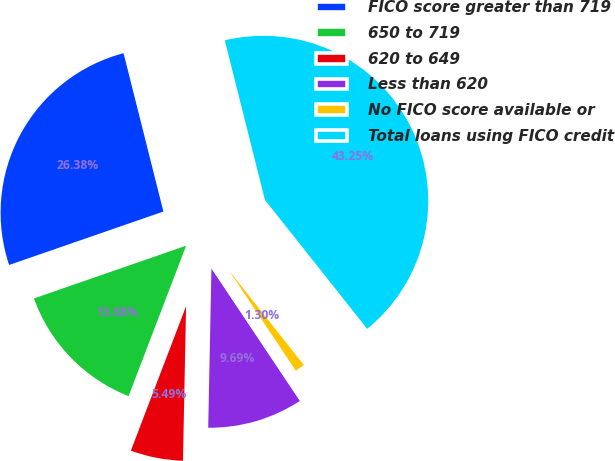Convert chart to OTSL. <chart><loc_0><loc_0><loc_500><loc_500><pie_chart><fcel>FICO score greater than 719<fcel>650 to 719<fcel>620 to 649<fcel>Less than 620<fcel>No FICO score available or<fcel>Total loans using FICO credit<nl><fcel>26.38%<fcel>13.88%<fcel>5.49%<fcel>9.69%<fcel>1.3%<fcel>43.25%<nl></chart> 